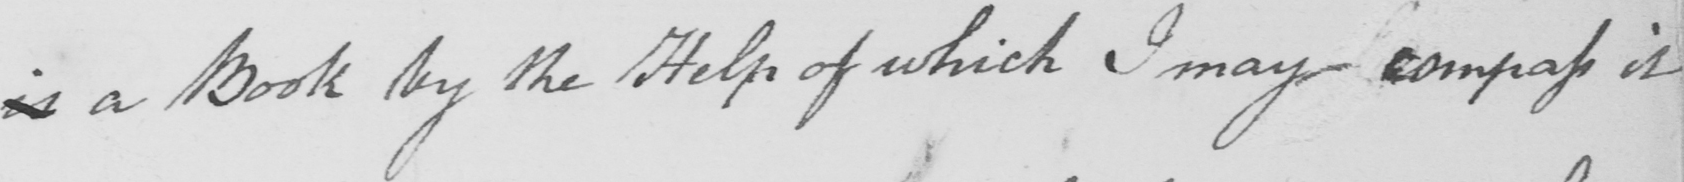What text is written in this handwritten line? is a Book by the Help of which I may compass it 